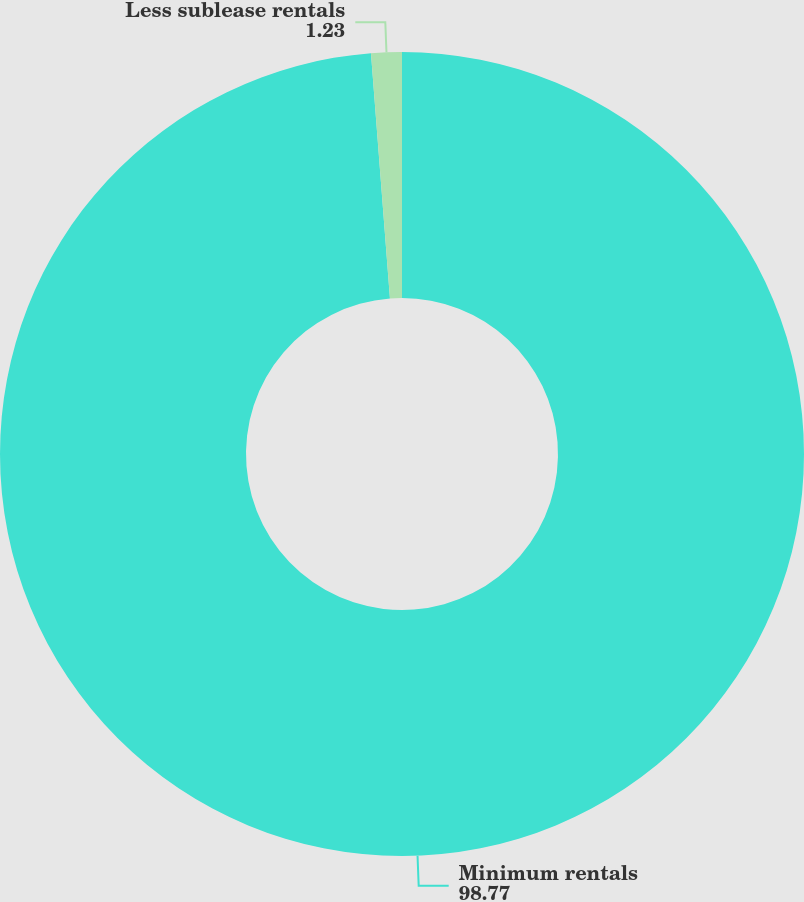Convert chart to OTSL. <chart><loc_0><loc_0><loc_500><loc_500><pie_chart><fcel>Minimum rentals<fcel>Less sublease rentals<nl><fcel>98.77%<fcel>1.23%<nl></chart> 